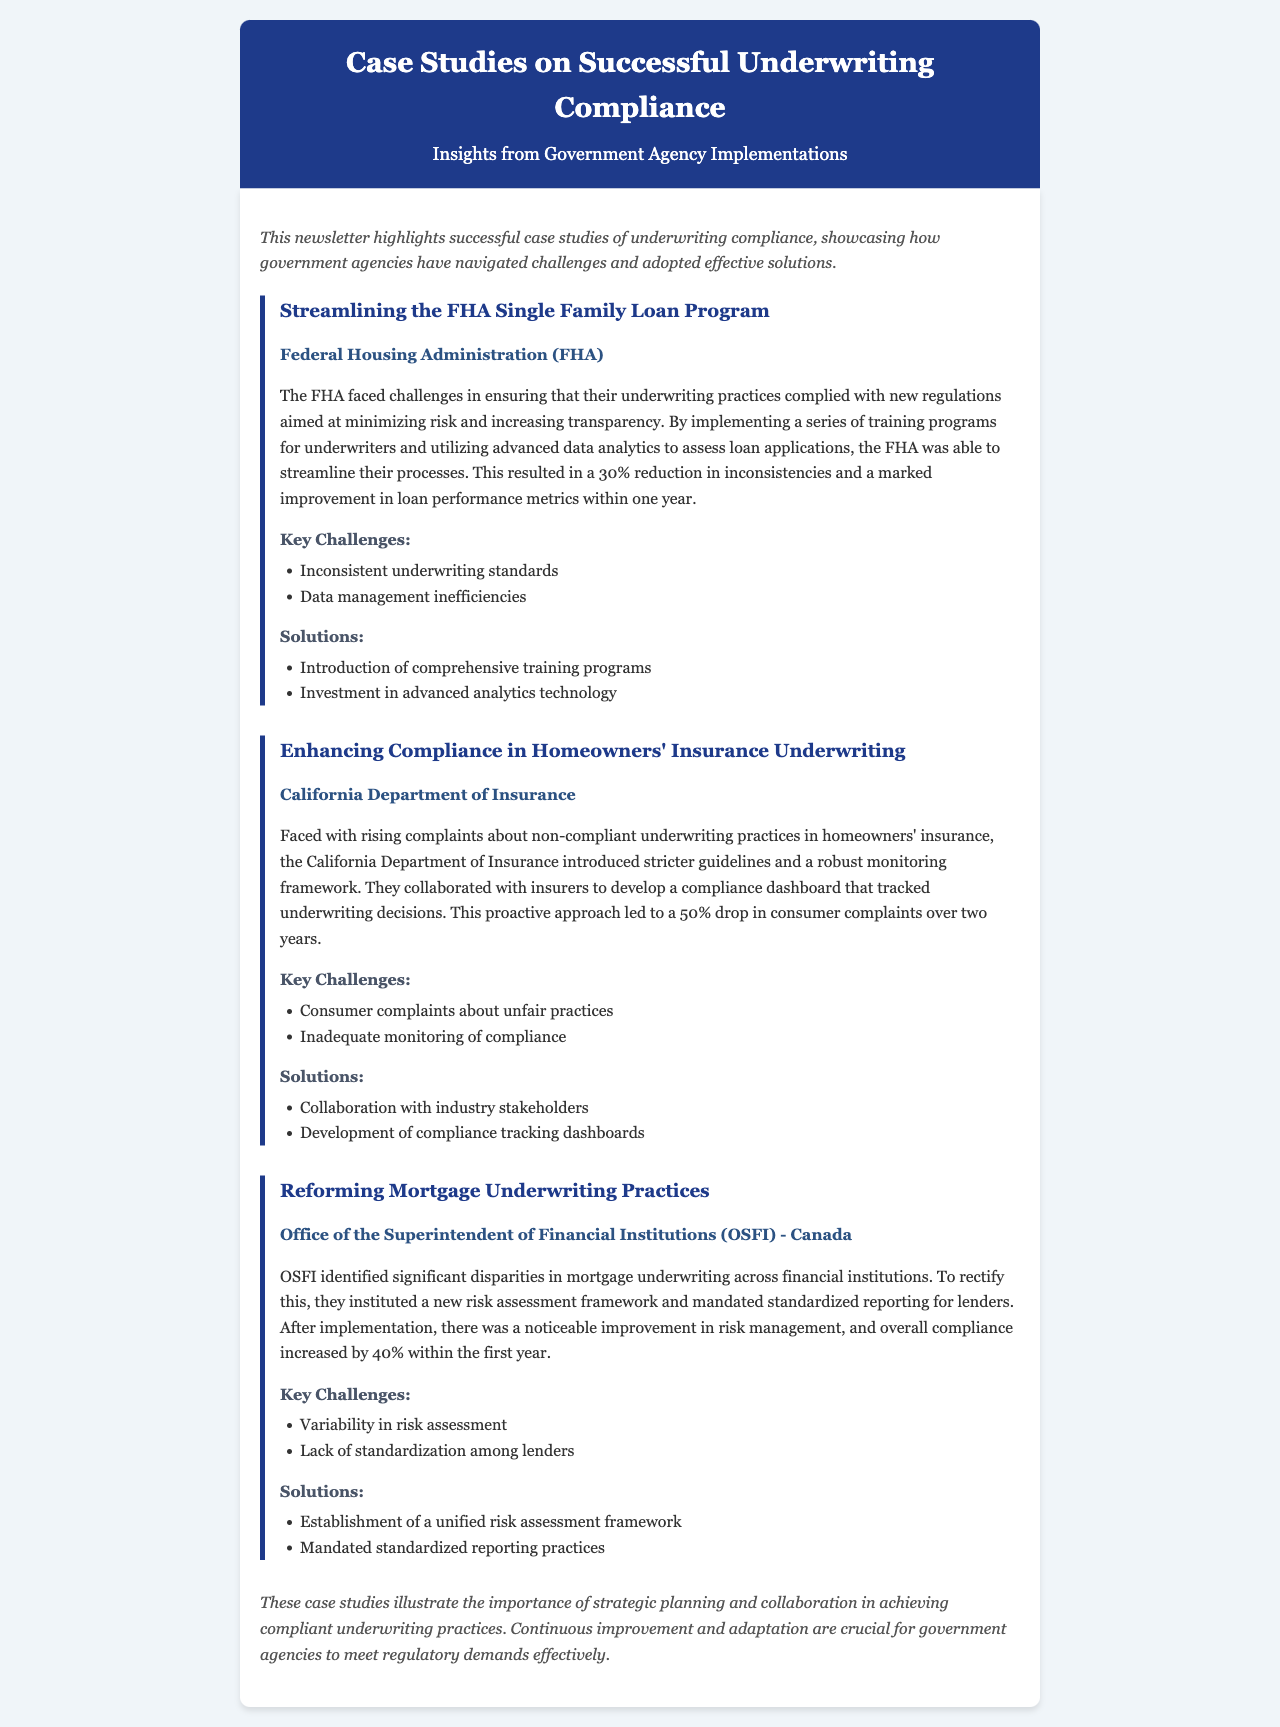what is the title of the newsletter? The title is prominently displayed at the top of the document, clearly indicating the subject matter.
Answer: Case Studies on Successful Underwriting Compliance which agency streamlined the FHA Single Family Loan Program? This information can be found within the first case study section of the document, which specifies the agency involved.
Answer: Federal Housing Administration (FHA) what percentage reduction in inconsistencies did the FHA achieve? The document states the outcome of the FHA's initiatives as a specific percentage, highlighting their success.
Answer: 30% what was introduced by the California Department of Insurance to track underwriting decisions? This detail is mentioned in the second case study, outlining a specific tool or method the agency implemented.
Answer: Compliance dashboard how much did consumer complaints drop after the California Department of Insurance's changes? The document quantifies the outcome of the changes in terms of complaint reduction, providing a clear statistic.
Answer: 50% what key challenge did OSFI face in mortgage underwriting practices? The case study regarding OSFI lists challenges faced, identifying significant issues the agency encountered.
Answer: Variability in risk assessment what framework did OSFI establish to improve risk management? The document describes a specific response to the challenges faced by OSFI, focused on improving practices.
Answer: Unified risk assessment framework what are its key components for successful underwriting compliance as highlighted in the conclusion? The conclusion summarizes major themes observed across the case studies, reflecting on effective strategies.
Answer: Strategic planning and collaboration 